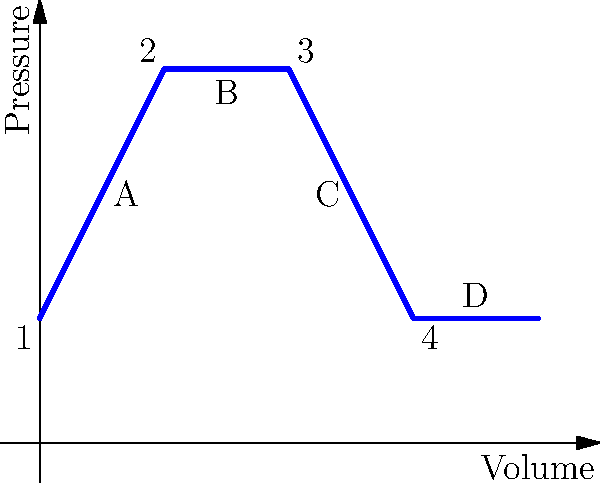In the pressure-volume diagram of an ideal gas in a four-stroke engine cycle shown above, which process represents the power stroke where the gas expands and performs work on the piston? To identify the power stroke in a four-stroke engine cycle, we need to understand the characteristics of each stroke and how they appear on a P-V diagram:

1. Intake stroke: Low pressure, increasing volume
2. Compression stroke: Increasing pressure, decreasing volume
3. Power stroke: Decreasing pressure, increasing volume
4. Exhaust stroke: Low pressure, decreasing volume

Looking at the P-V diagram:

1. Process 1-2 (A): Increasing pressure, decreasing volume - This is the compression stroke
2. Process 2-3 (B): Constant pressure, increasing volume - This is not a typical process in a four-stroke cycle
3. Process 3-4 (C): Decreasing pressure, increasing volume - This matches the characteristics of the power stroke
4. Process 4-1 (D): Constant pressure, decreasing volume - This approximates the exhaust stroke

The power stroke is where the gas expands and performs work on the piston. This is represented by a decrease in pressure and an increase in volume. Therefore, the process that represents the power stroke is Process 3-4, labeled as C on the diagram.
Answer: Process C (3-4) 